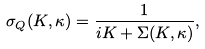Convert formula to latex. <formula><loc_0><loc_0><loc_500><loc_500>\sigma _ { Q } ( K , \kappa ) = \frac { 1 } { i K + \Sigma ( K , \kappa ) } ,</formula> 